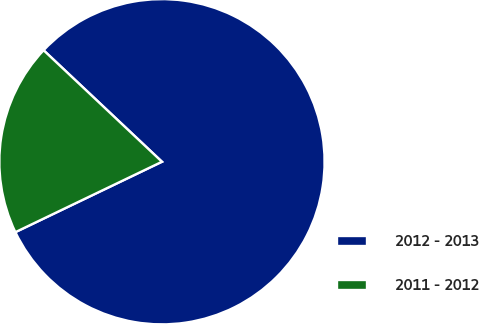<chart> <loc_0><loc_0><loc_500><loc_500><pie_chart><fcel>2012 - 2013<fcel>2011 - 2012<nl><fcel>80.85%<fcel>19.15%<nl></chart> 